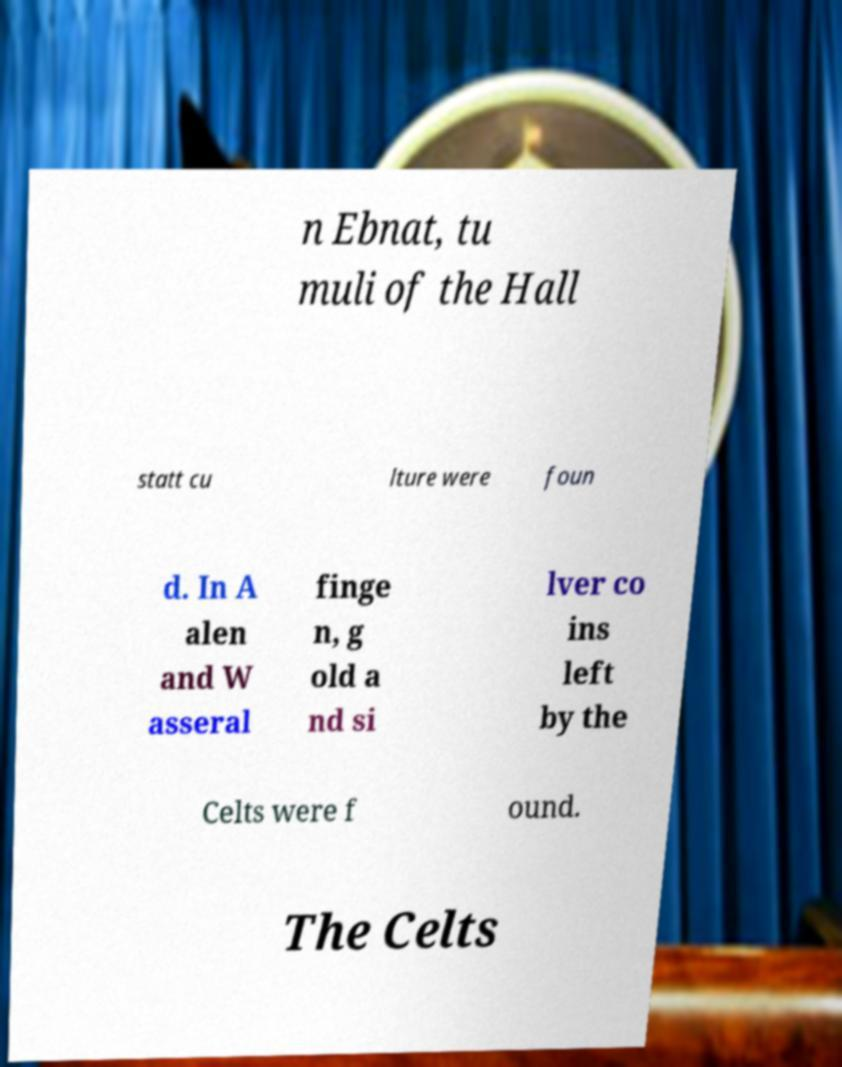What messages or text are displayed in this image? I need them in a readable, typed format. n Ebnat, tu muli of the Hall statt cu lture were foun d. In A alen and W asseral finge n, g old a nd si lver co ins left by the Celts were f ound. The Celts 